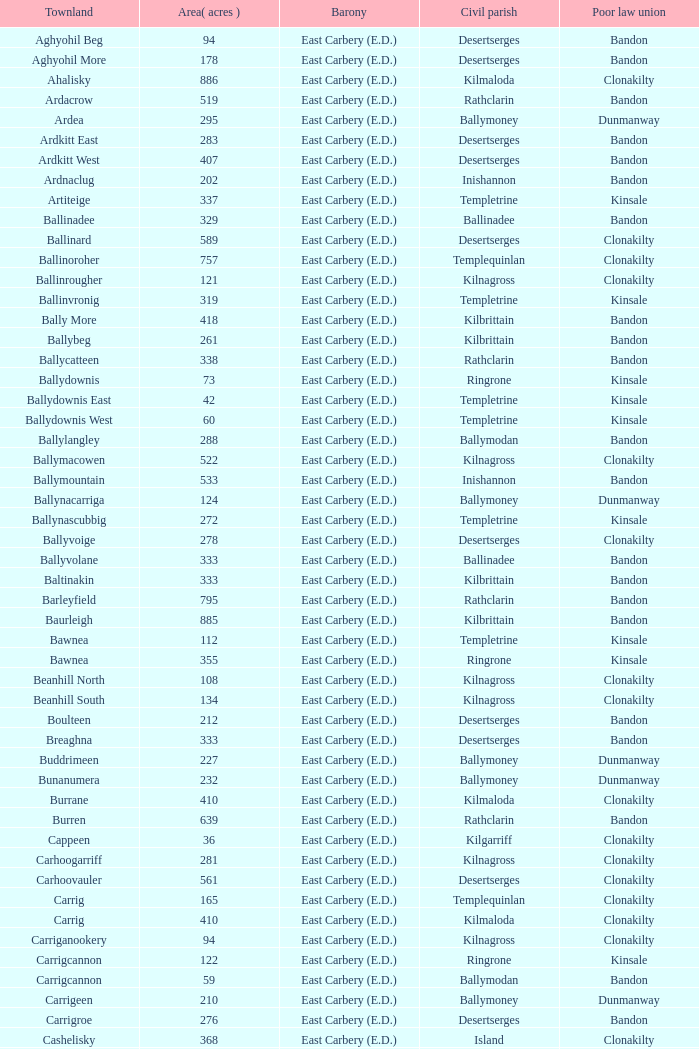What is the maximal size (in acres) of the knockacullen townland? 381.0. 